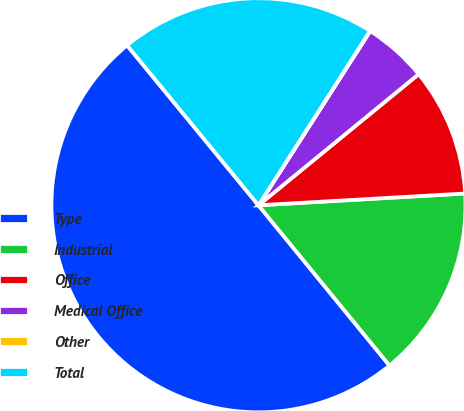Convert chart to OTSL. <chart><loc_0><loc_0><loc_500><loc_500><pie_chart><fcel>Type<fcel>Industrial<fcel>Office<fcel>Medical Office<fcel>Other<fcel>Total<nl><fcel>49.96%<fcel>15.0%<fcel>10.01%<fcel>5.01%<fcel>0.02%<fcel>20.0%<nl></chart> 